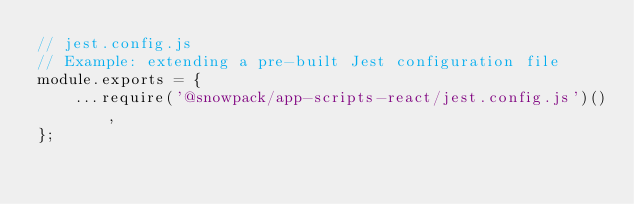<code> <loc_0><loc_0><loc_500><loc_500><_JavaScript_>// jest.config.js
// Example: extending a pre-built Jest configuration file
module.exports = {
    ...require('@snowpack/app-scripts-react/jest.config.js')(),
};
</code> 